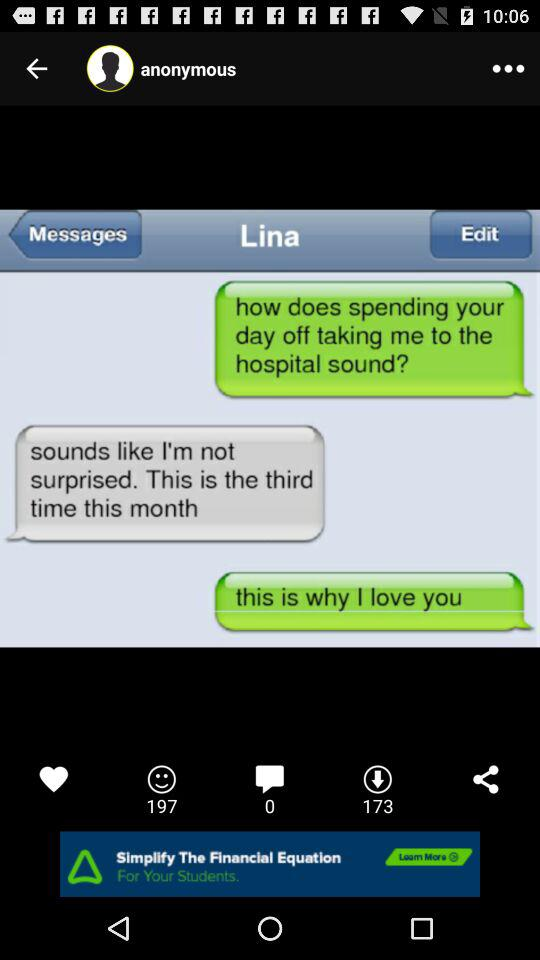What is the number of manges?
When the provided information is insufficient, respond with <no answer>. <no answer> 